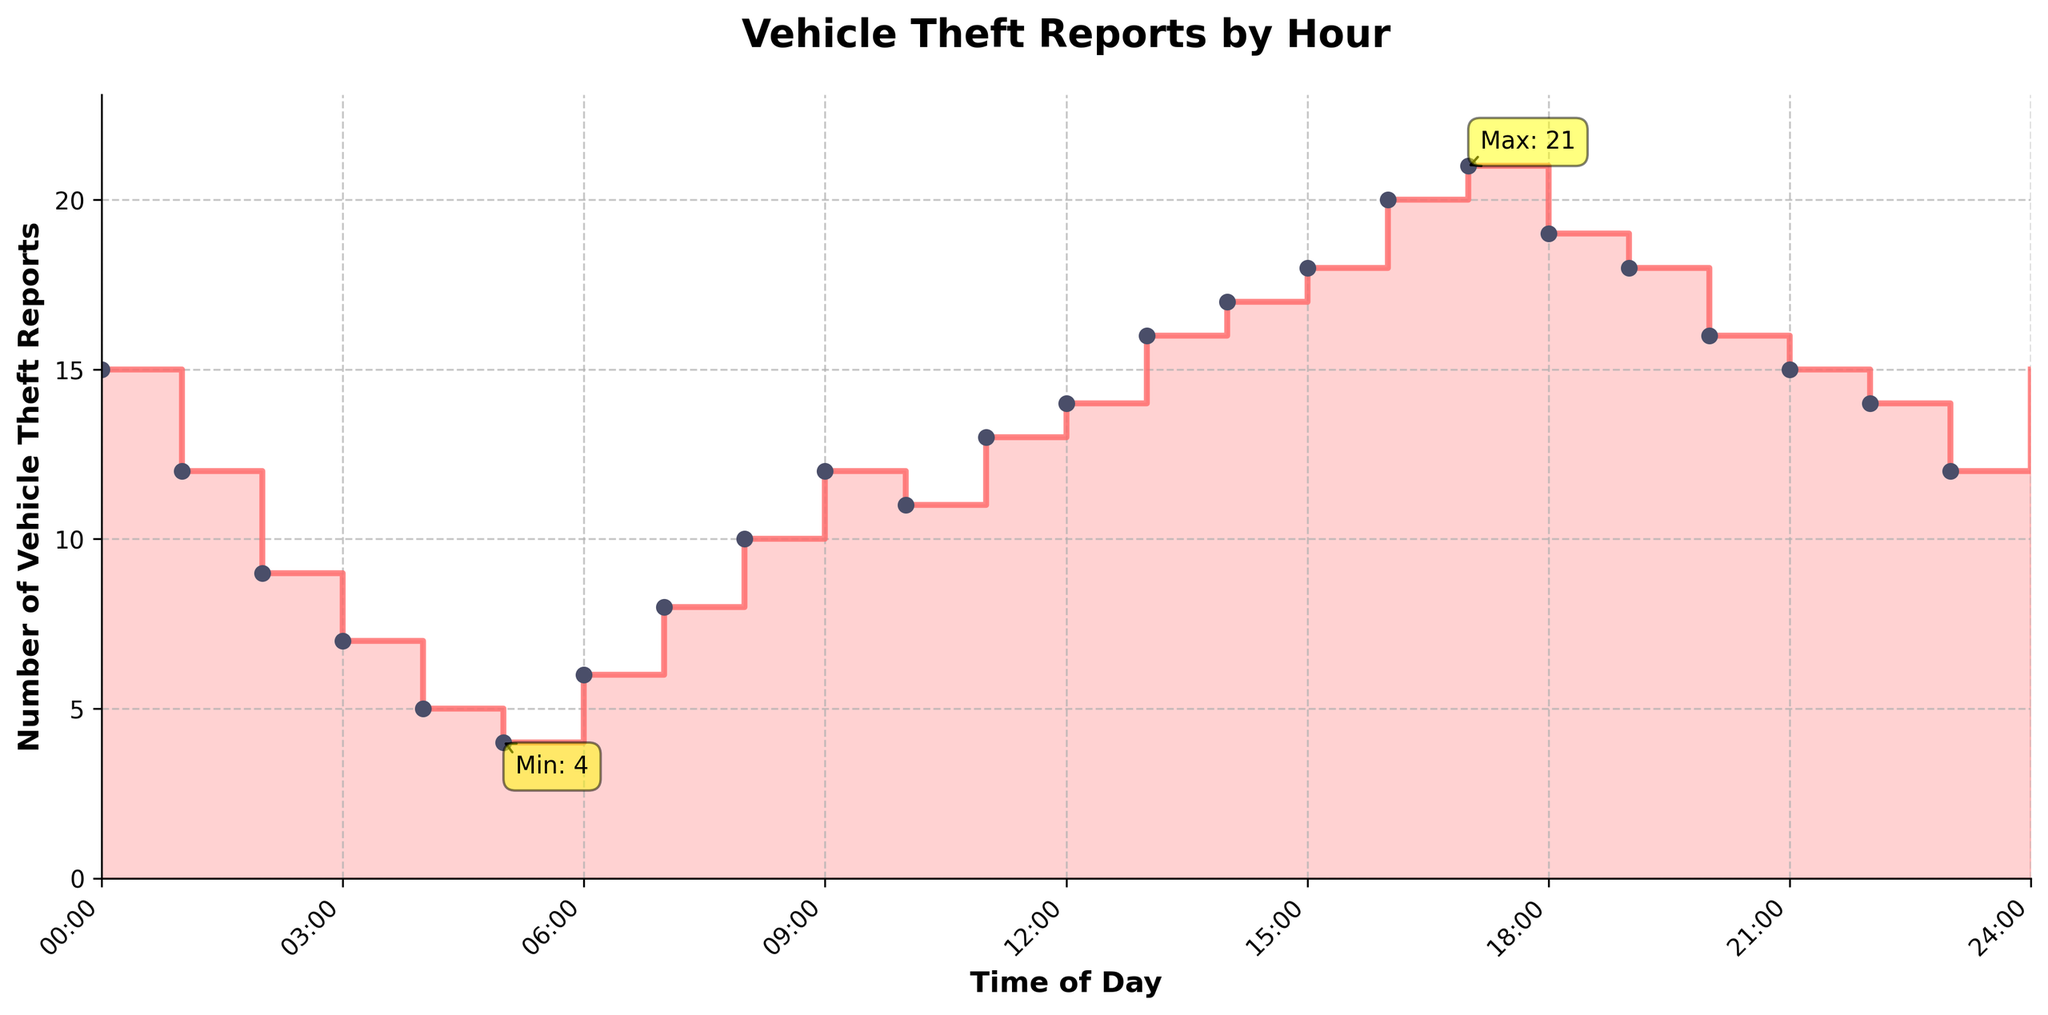What is the title of the plot? The title of the plot is usually located at the top of the figure and provides a summary of the information presented in the chart, in this case, it is explicitly labeled.
Answer: Vehicle Theft Reports by Hour How many vehicle theft reports were recorded at 15:00-16:00? Referring to the stair plot, the data point corresponding to the 15:00-16:00 time range indicates the number of reports.
Answer: 18 At what hour is the number of vehicle theft reports the highest, and what is the value? The highest number of vehicle theft reports is indicated on the plot by an annotation. Observing this annotation will reveal both the hour and the value.
Answer: 17:00-18:00, 21 Compare the number of vehicle theft reports between 02:00-03:00 and 06:00-07:00. Which hour has more reports? Locate the data points for both time ranges on the plot and compare their values.
Answer: 02:00-03:00 has more reports What is the total number of vehicle theft reports between 10:00 and 12:00? Add the values for the time ranges 10:00-11:00 and 11:00-12:00 as shown on the plot.
Answer: 11 + 13 = 24 How does the number of reports at 05:00-06:00 compare with the number at 23:00-00:00? Find and compare the values for these two time ranges on the plot.
Answer: 23:00-00:00 has 12 reports, while 05:00-06:00 has 4, so 23:00-00:00 has more Which hour has the fewest vehicle theft reports, and what is the value? The hour with the fewest reports is marked with an annotation on the plot, indicating the exact value and time.
Answer: 05:00-06:00, 4 Identify the hours with exactly 12 vehicle theft reports. Look at the data points on the plot to find the hours that match the value of 12.
Answer: 01:00-02:00, 09:00-10:00, 23:00-00:00 How many hours have vehicle theft reports greater than 15? Observe the plot to count the hours where the reported values exceed 15.
Answer: 7 hours What is the average number of vehicle theft reports between 12:00 and 15:00? Sum the values for 12:00-13:00, 13:00-14:00, and 14:00-15:00, then divide by 3 to find the average.
Answer: (14 + 16 + 17) / 3 = 15.67 